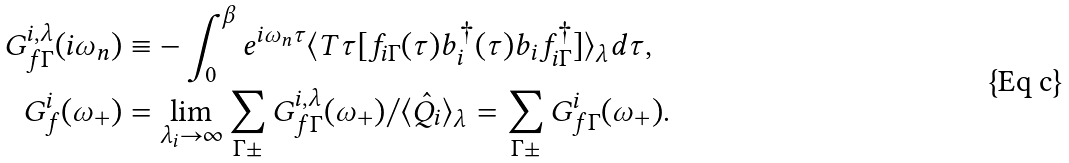Convert formula to latex. <formula><loc_0><loc_0><loc_500><loc_500>G ^ { i , \lambda } _ { f \Gamma } ( i \omega _ { n } ) & \equiv - \int _ { 0 } ^ { \beta } e ^ { i \omega _ { n } \tau } \langle T \tau [ f _ { i \Gamma } ( \tau ) b _ { i } ^ { \dag } ( \tau ) b _ { i } f _ { i \Gamma } ^ { \dag } ] \rangle _ { \lambda } d \tau , \\ G ^ { i } _ { f } ( \omega _ { + } ) & = \lim _ { \lambda _ { i } \rightarrow \infty } \sum _ { \Gamma \pm } G ^ { i , \lambda } _ { f \Gamma } ( \omega _ { + } ) / \langle \hat { Q } _ { i } \rangle _ { \lambda } = \sum _ { \Gamma \pm } G _ { f \Gamma } ^ { i } ( \omega _ { + } ) .</formula> 